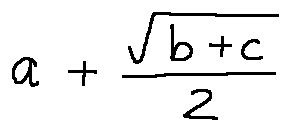Convert formula to latex. <formula><loc_0><loc_0><loc_500><loc_500>a + \frac { \sqrt { b + c } } { 2 }</formula> 